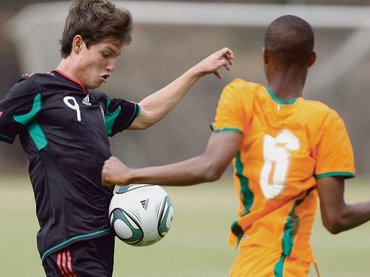Identify and read out the text in this image. 6 9 